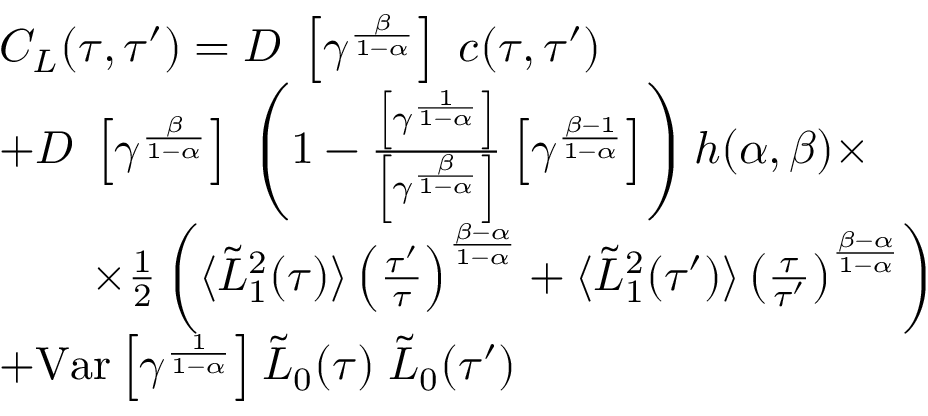Convert formula to latex. <formula><loc_0><loc_0><loc_500><loc_500>\begin{array} { r l } & { C _ { L } ( \tau , \tau ^ { \prime } ) = D \, \left [ \gamma ^ { \frac { \beta } { 1 - \alpha } } \right ] \, c ( \tau , \tau ^ { \prime } ) } \\ & { + D \, \left [ \gamma ^ { \frac { \beta } { 1 - \alpha } } \right ] \, \left ( 1 - \frac { \left [ \gamma ^ { \frac { 1 } { 1 - \alpha } } \right ] } { \left [ \gamma ^ { \frac { \beta } { 1 - \alpha } } \right ] } \left [ \gamma ^ { \frac { \beta - 1 } { 1 - \alpha } } \right ] \right ) h ( \alpha , \beta ) \times } \\ & { \quad \times \frac { 1 } { 2 } \left ( \langle \tilde { L } _ { 1 } ^ { 2 } ( \tau ) \rangle \left ( \frac { \tau ^ { \prime } } { \tau } \right ) ^ { \frac { \beta - \alpha } { 1 - \alpha } } + \langle \tilde { L } _ { 1 } ^ { 2 } ( \tau ^ { \prime } ) \rangle \left ( \frac { \tau } { \tau ^ { \prime } } \right ) ^ { \frac { \beta - \alpha } { 1 - \alpha } } \right ) } \\ & { + V a r \left [ \gamma ^ { \frac { 1 } { 1 - \alpha } } \right ] \tilde { L } _ { 0 } ( \tau ) \, \tilde { L } _ { 0 } ( \tau ^ { \prime } ) } \end{array}</formula> 